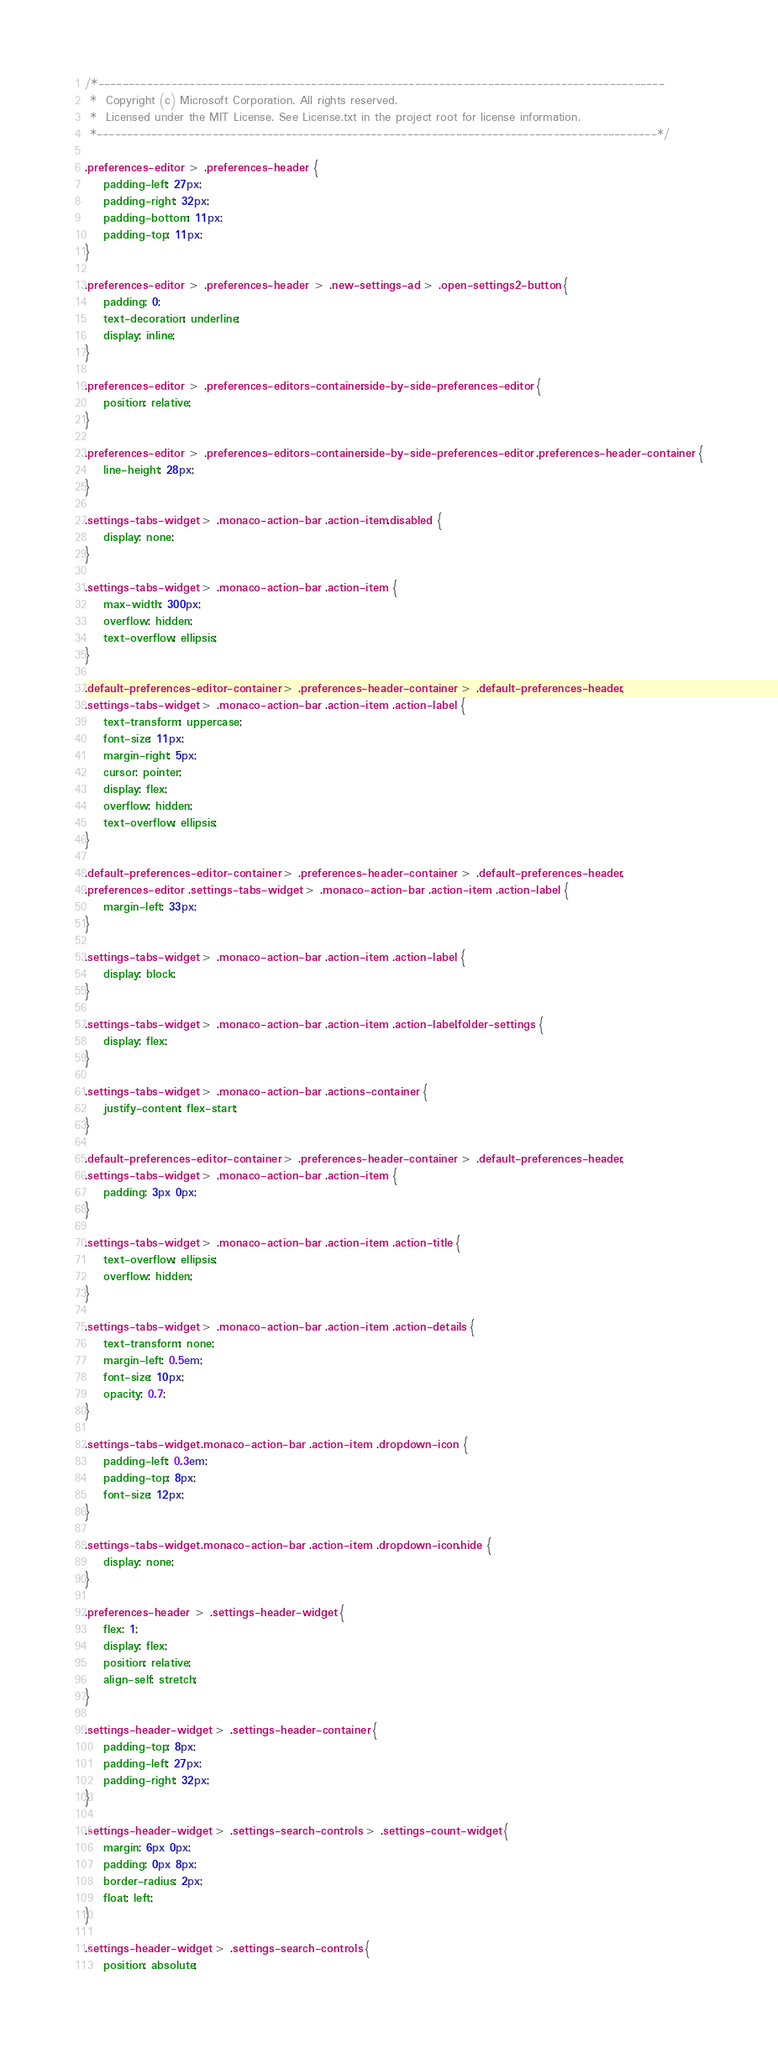<code> <loc_0><loc_0><loc_500><loc_500><_CSS_>/*---------------------------------------------------------------------------------------------
 *  Copyright (c) Microsoft Corporation. All rights reserved.
 *  Licensed under the MIT License. See License.txt in the project root for license information.
 *--------------------------------------------------------------------------------------------*/

.preferences-editor > .preferences-header {
	padding-left: 27px;
	padding-right: 32px;
	padding-bottom: 11px;
	padding-top: 11px;
}

.preferences-editor > .preferences-header > .new-settings-ad > .open-settings2-button {
	padding: 0;
	text-decoration: underline;
	display: inline;
}

.preferences-editor > .preferences-editors-container.side-by-side-preferences-editor {
	position: relative;
}

.preferences-editor > .preferences-editors-container.side-by-side-preferences-editor .preferences-header-container {
	line-height: 28px;
}

.settings-tabs-widget > .monaco-action-bar .action-item.disabled {
	display: none;
}

.settings-tabs-widget > .monaco-action-bar .action-item {
	max-width: 300px;
	overflow: hidden;
	text-overflow: ellipsis;
}

.default-preferences-editor-container > .preferences-header-container > .default-preferences-header,
.settings-tabs-widget > .monaco-action-bar .action-item .action-label {
	text-transform: uppercase;
	font-size: 11px;
	margin-right: 5px;
	cursor: pointer;
	display: flex;
	overflow: hidden;
	text-overflow: ellipsis;
}

.default-preferences-editor-container > .preferences-header-container > .default-preferences-header,
.preferences-editor .settings-tabs-widget > .monaco-action-bar .action-item .action-label {
	margin-left: 33px;
}

.settings-tabs-widget > .monaco-action-bar .action-item .action-label {
	display: block;
}

.settings-tabs-widget > .monaco-action-bar .action-item .action-label.folder-settings {
	display: flex;
}

.settings-tabs-widget > .monaco-action-bar .actions-container {
	justify-content: flex-start;
}

.default-preferences-editor-container > .preferences-header-container > .default-preferences-header,
.settings-tabs-widget > .monaco-action-bar .action-item {
	padding: 3px 0px;
}

.settings-tabs-widget > .monaco-action-bar .action-item .action-title {
	text-overflow: ellipsis;
	overflow: hidden;
}

.settings-tabs-widget > .monaco-action-bar .action-item .action-details {
	text-transform: none;
	margin-left: 0.5em;
	font-size: 10px;
	opacity: 0.7;
}

.settings-tabs-widget .monaco-action-bar .action-item .dropdown-icon {
	padding-left: 0.3em;
	padding-top: 8px;
	font-size: 12px;
}

.settings-tabs-widget .monaco-action-bar .action-item .dropdown-icon.hide {
	display: none;
}

.preferences-header > .settings-header-widget {
	flex: 1;
	display: flex;
	position: relative;
	align-self: stretch;
}

.settings-header-widget > .settings-header-container {
	padding-top: 8px;
	padding-left: 27px;
	padding-right: 32px;
}

.settings-header-widget > .settings-search-controls > .settings-count-widget {
	margin: 6px 0px;
	padding: 0px 8px;
	border-radius: 2px;
	float: left;
}

.settings-header-widget > .settings-search-controls {
	position: absolute;</code> 